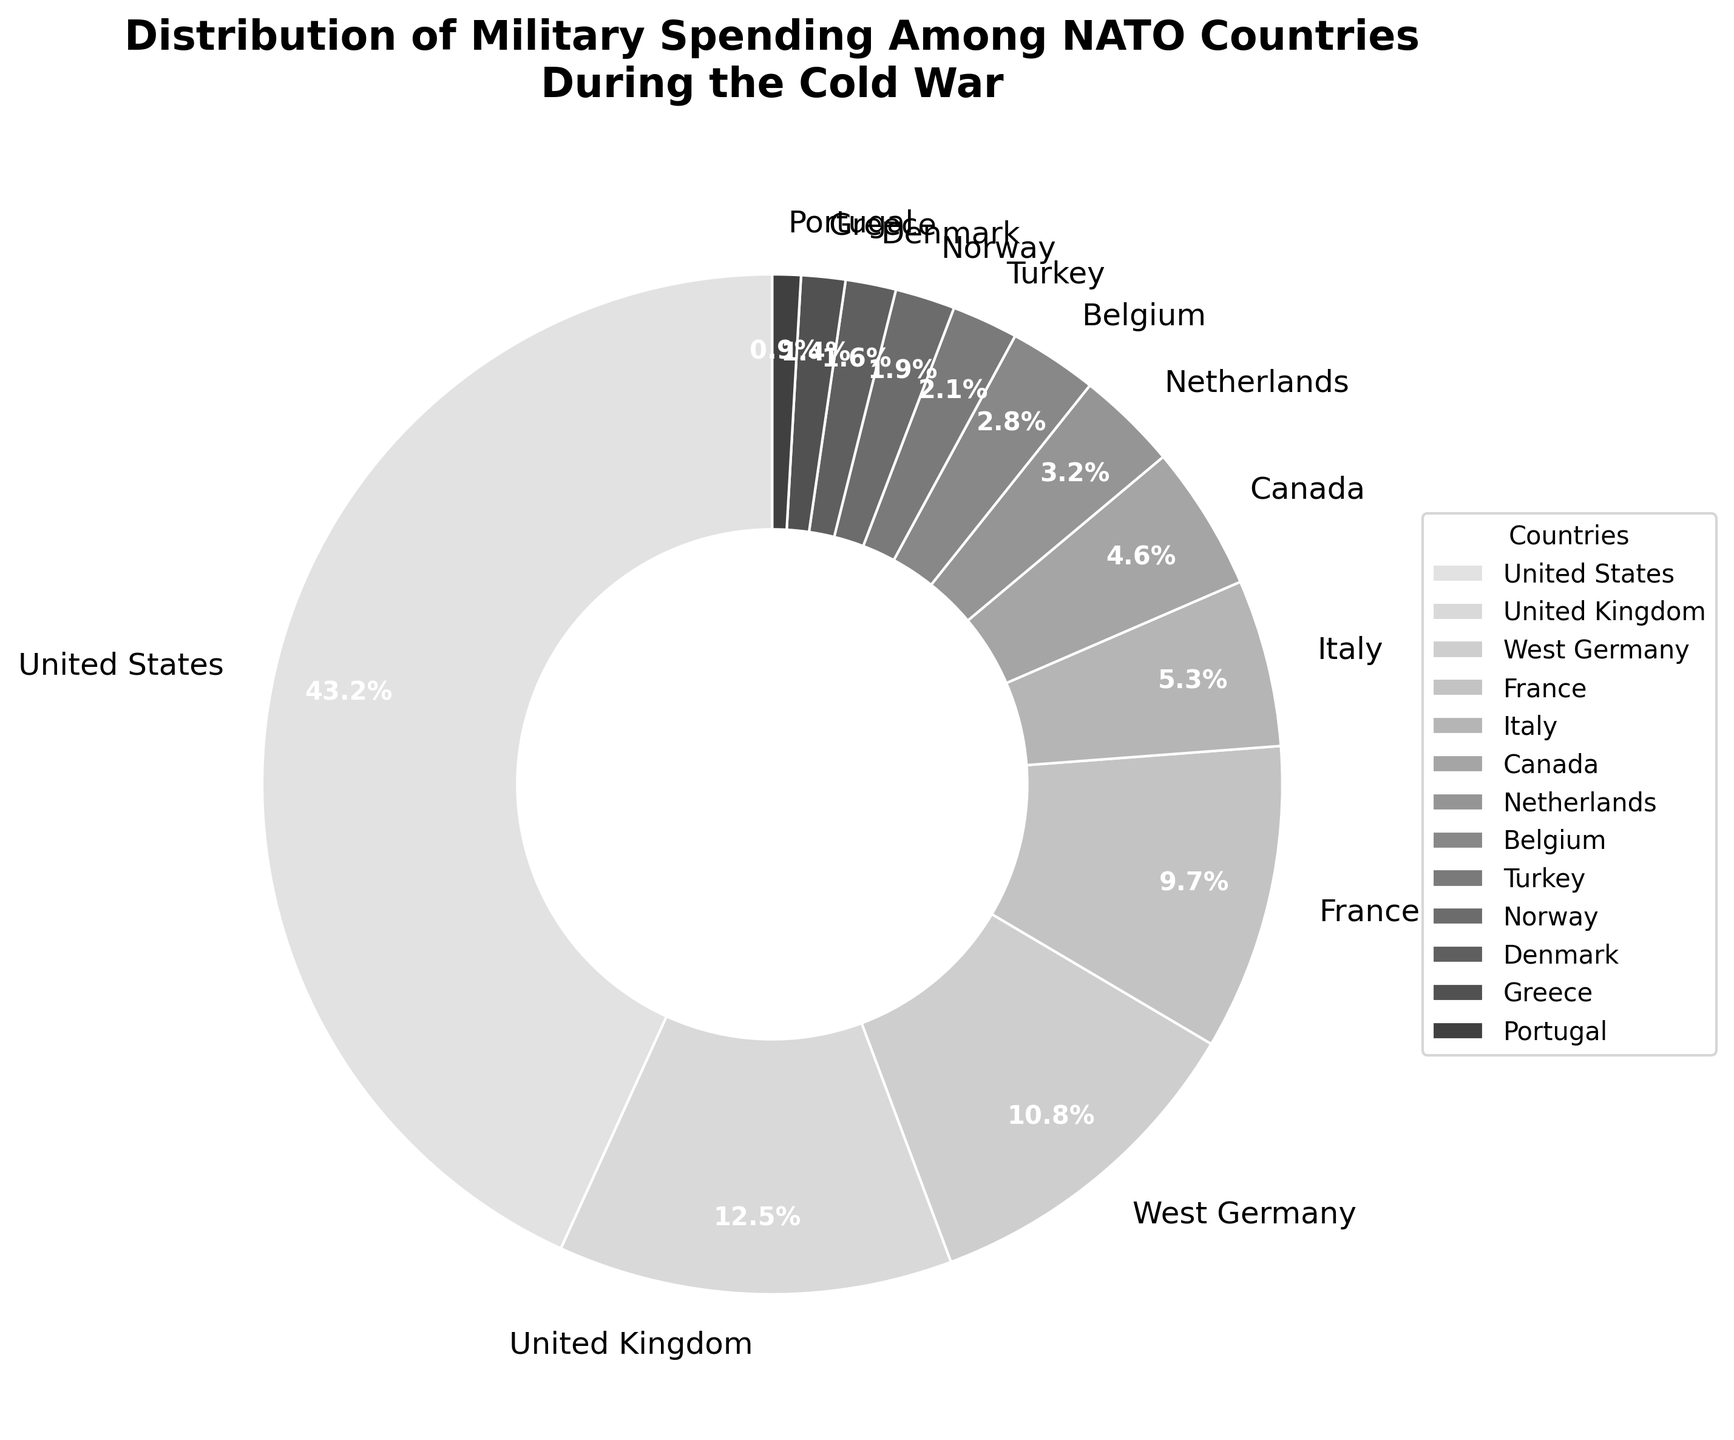What is the percentage of military spending by the United States? Locate the segment labeled "United States" in the pie chart and read the percentage value inside or adjacent to it.
Answer: 43.2% Which country has the second highest military spending and what is the percentage? Identify the segment with the second largest area after the United States. The label next to this segment shows "United Kingdom." Read the percentage value inside or adjacent to it.
Answer: United Kingdom, 12.5% What is the combined military spending percentage of West Germany and France? Find the segments labeled "West Germany" and "France" in the pie chart, then add their percentages together: 10.8% + 9.7%.
Answer: 20.5% How much more is the military spending percentage of the United States compared to West Germany? Subtract the percentage of West Germany from that of the United States: 43.2% - 10.8%.
Answer: 32.4% Which countries have a military spending percentage less than 5%? Identify and list the segments with percentages less than 5% by looking at the labels and their adjacent percentage values.
Answer: Canada, Netherlands, Belgium, Turkey, Norway, Denmark, Greece, Portugal What is the average military spending percentage of Italy, Canada, and the Netherlands? Sum the percentages of Italy (5.3%), Canada (4.6%), and Netherlands (3.2%) and then divide by 3: (5.3 + 4.6 + 3.2) / 3.
Answer: 4.37% Which country contributes the smallest percentage to NATO's military spending according to the chart? Locate the segment with the smallest area in the pie chart and read its label. The label next to this segment shows "Portugal."
Answer: Portugal What is the total percentage of military spending by the United States, United Kingdom, and West Germany combined? Sum the percentages of the United States (43.2%), United Kingdom (12.5%), and West Germany (10.8%): 43.2 + 12.5 + 10.8.
Answer: 66.5% If Italy and Canada combined their military spending, would it surpass that of the United Kingdom? Add the percentages of Italy (5.3%) and Canada (4.6%) and compare to the United Kingdom's percentage: 5.3 + 4.6 = 9.9, which is less than 12.5.
Answer: No 